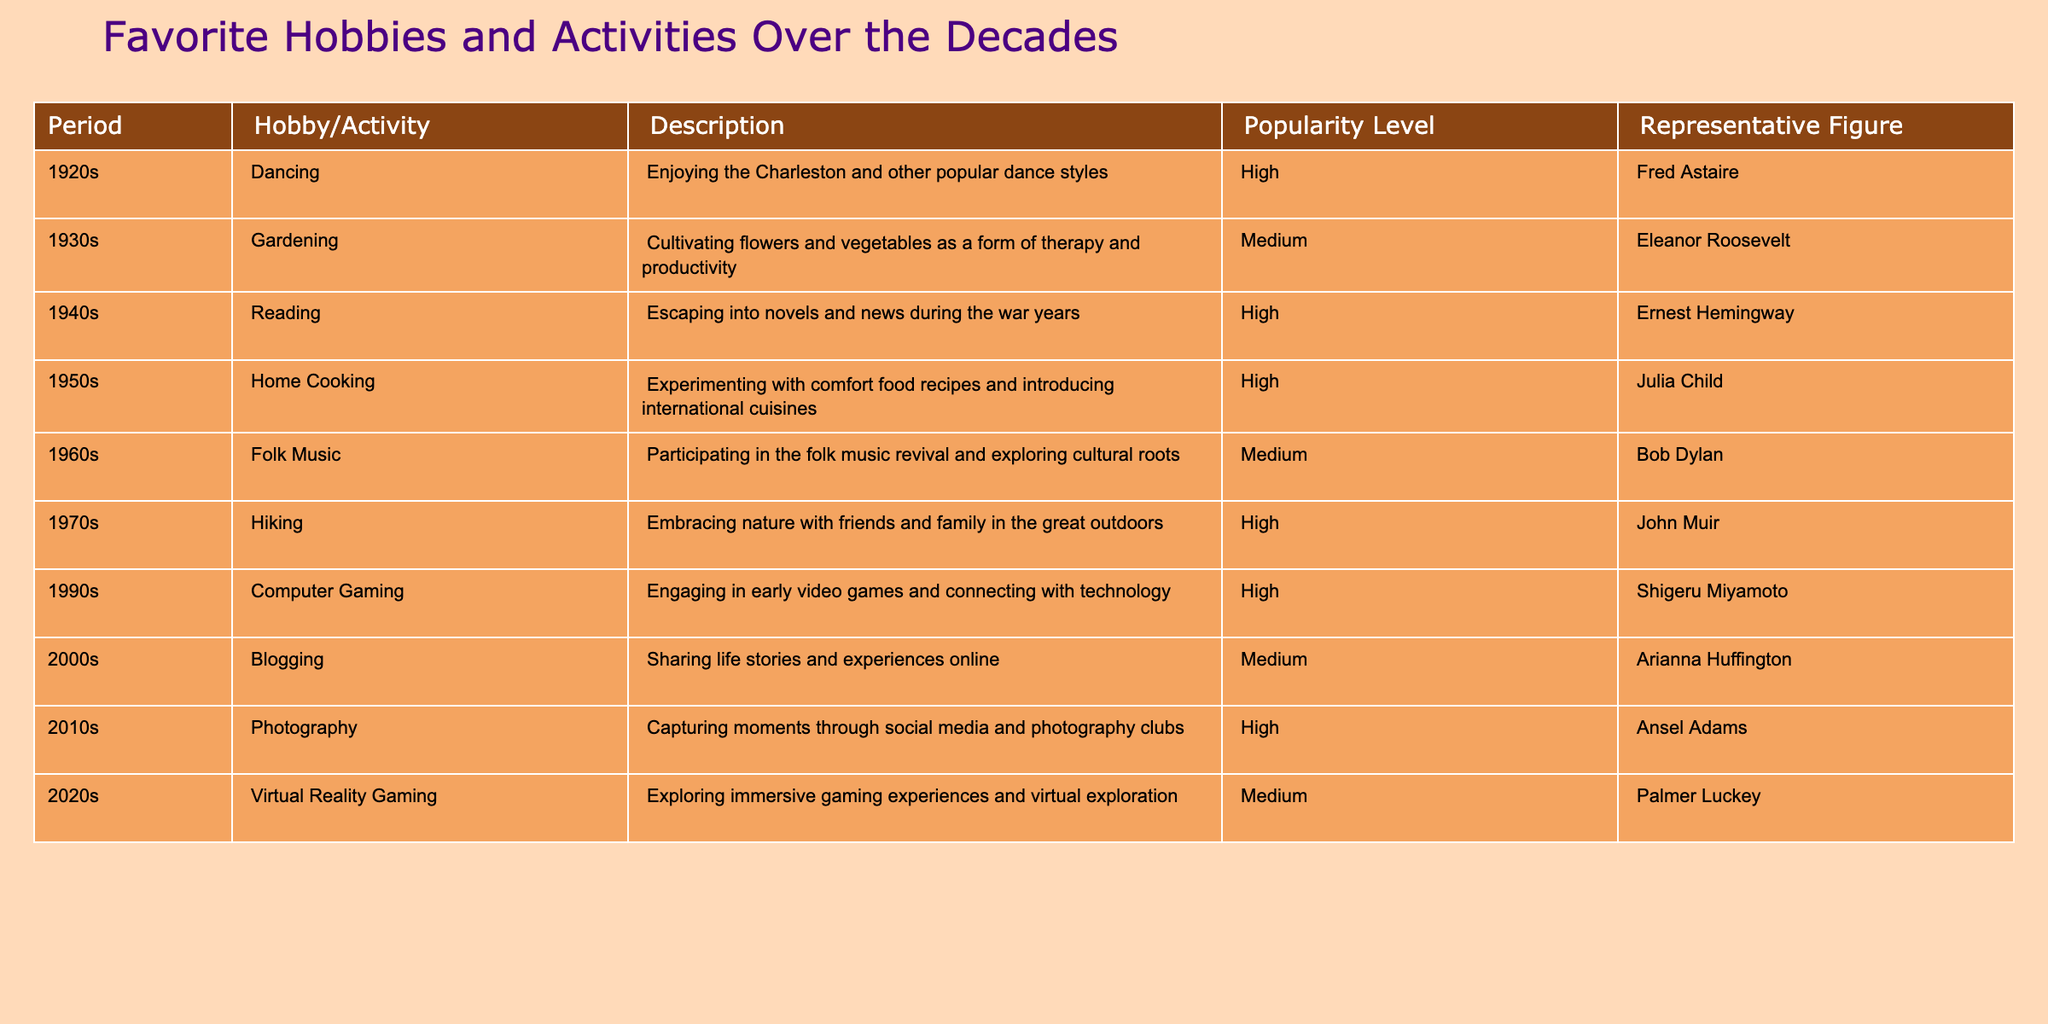What hobby/activity was most popular in the 1950s? According to the table, the most popular hobby in the 1950s was Home Cooking.
Answer: Home Cooking Which hobby/activity is associated with the highest popularity level over all decades? The hobbies/activities with the highest popularity level are Dancing, Reading, Home Cooking, Hiking, Computer Gaming, Photography; there are multiple entries, but to answer, we only need to name one of them, which is Dancing.
Answer: Dancing How many hobbies/activities have a medium popularity level? From the table, there are three activities listed with medium popularity levels: Gardening, Folk Music, and Blogging. Counting them gives us a total of three.
Answer: 3 Is there any hobby/activity associated with a representative figure from the 2020s? Yes, the hobby/activity from the 2020s is Virtual Reality Gaming, and the representative figure is Palmer Luckey.
Answer: Yes Which decade had the least popular hobby/activity, and what was it? From the table, the only decade with a medium popular hobby/activity (Gardening, Folk Music, Blogging) indicates that the least popular activities are in the 1930s, 1960s, and 2000s. Since we are picking one, I will arbitrarily choose Gardening.
Answer: Gardening What is the difference in popularity level between the hobbies in the 1940s and 1970s? The popularity level of the 1940s (Reading) is High, and for the 1970s (Hiking), it is also High. The difference in popularity levels is none, as both are categorized the same.
Answer: None Name two hobbies from the 2010s and 2020s that have a medium popularity level. The medium popularity activities from the table are Blogging from the 2000s and Virtual Reality Gaming from the 2020s. Only one activity per decade needs to be noted, and I must respond with both.
Answer: Blogging, Virtual Reality Gaming Which hobby/activity had the lowest popularity level in the 1960s? The hobby/activity in the 1960s with a medium popularity level is Folk Music, as it is the only entry from that decade.
Answer: Folk Music In which decade did a hobby/activity related to technology emerge? From the provided table, the 1990s is when Computer Gaming emerged as a hobby/activity related to technology.
Answer: 1990s 